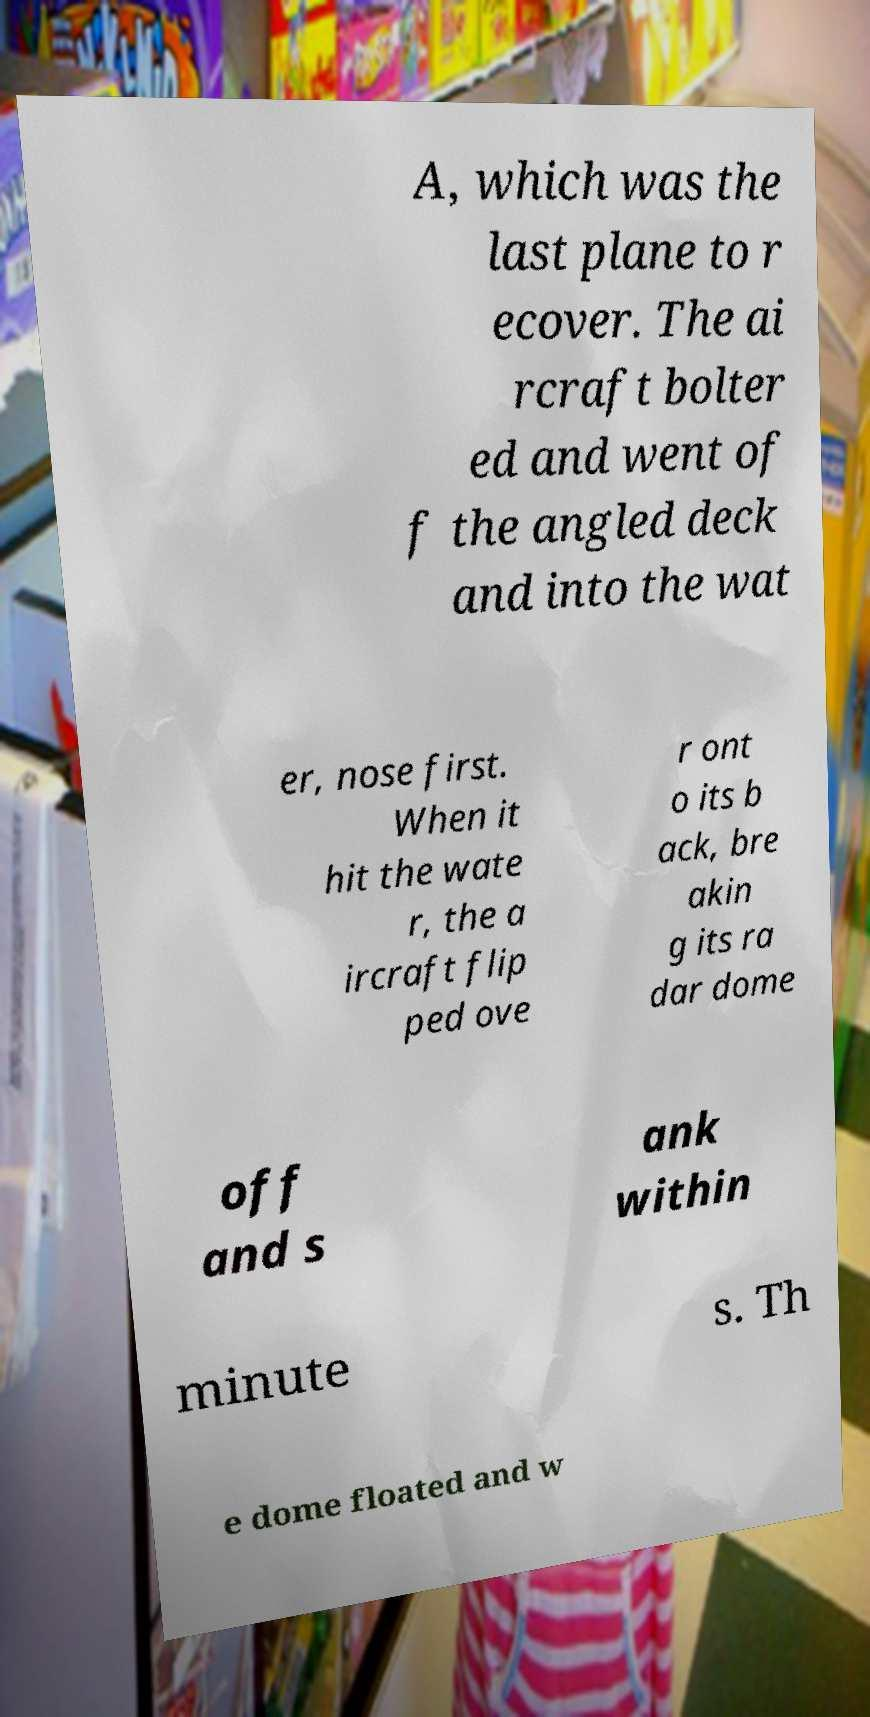There's text embedded in this image that I need extracted. Can you transcribe it verbatim? A, which was the last plane to r ecover. The ai rcraft bolter ed and went of f the angled deck and into the wat er, nose first. When it hit the wate r, the a ircraft flip ped ove r ont o its b ack, bre akin g its ra dar dome off and s ank within minute s. Th e dome floated and w 